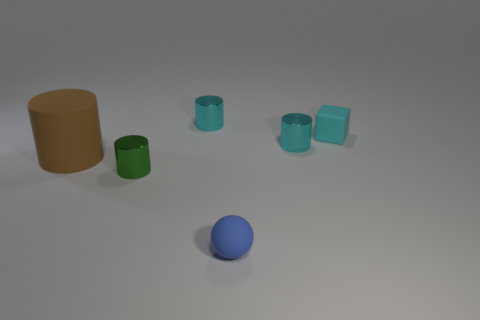Subtract all brown matte cylinders. How many cylinders are left? 3 Add 3 large brown rubber things. How many objects exist? 9 Subtract all cyan cylinders. How many cylinders are left? 2 Subtract all spheres. How many objects are left? 5 Add 2 small balls. How many small balls exist? 3 Subtract 1 brown cylinders. How many objects are left? 5 Subtract 1 spheres. How many spheres are left? 0 Subtract all blue cylinders. Subtract all cyan spheres. How many cylinders are left? 4 Subtract all gray blocks. How many cyan cylinders are left? 2 Subtract all matte cylinders. Subtract all big green rubber spheres. How many objects are left? 5 